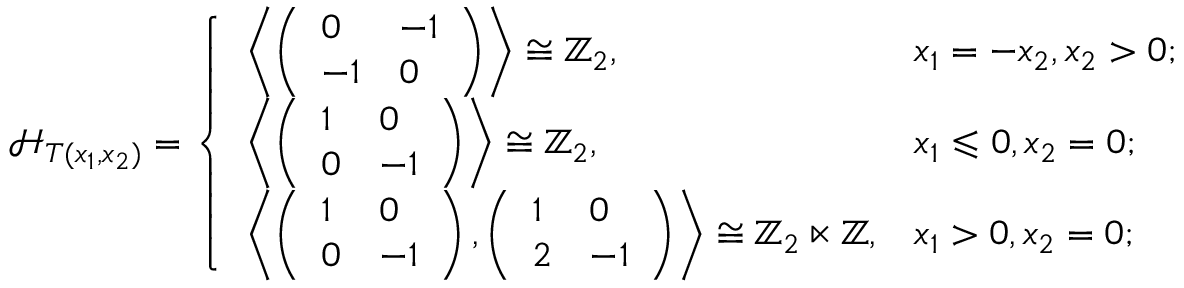Convert formula to latex. <formula><loc_0><loc_0><loc_500><loc_500>{ \mathcal { H } } _ { T ( x _ { 1 } , x _ { 2 } ) } = \left \{ \begin{array} { l l } { \left \langle \left ( \begin{array} { l l } { 0 } & { - 1 } \\ { - 1 } & { 0 } \end{array} \right ) \right \rangle \cong \mathbb { Z } _ { 2 } , } & { x _ { 1 } = - x _ { 2 } , x _ { 2 } > 0 ; } \\ { \left \langle \left ( \begin{array} { l l } { 1 } & { 0 } \\ { 0 } & { - 1 } \end{array} \right ) \right \rangle \cong \mathbb { Z } _ { 2 } , } & { x _ { 1 } \leqslant 0 , x _ { 2 } = 0 ; } \\ { \left \langle \left ( \begin{array} { l l } { 1 } & { 0 } \\ { 0 } & { - 1 } \end{array} \right ) , \left ( \begin{array} { l l } { 1 } & { 0 } \\ { 2 } & { - 1 } \end{array} \right ) \right \rangle \cong \mathbb { Z } _ { 2 } \ltimes \mathbb { Z } , } & { x _ { 1 } > 0 , x _ { 2 } = 0 ; } \end{array}</formula> 